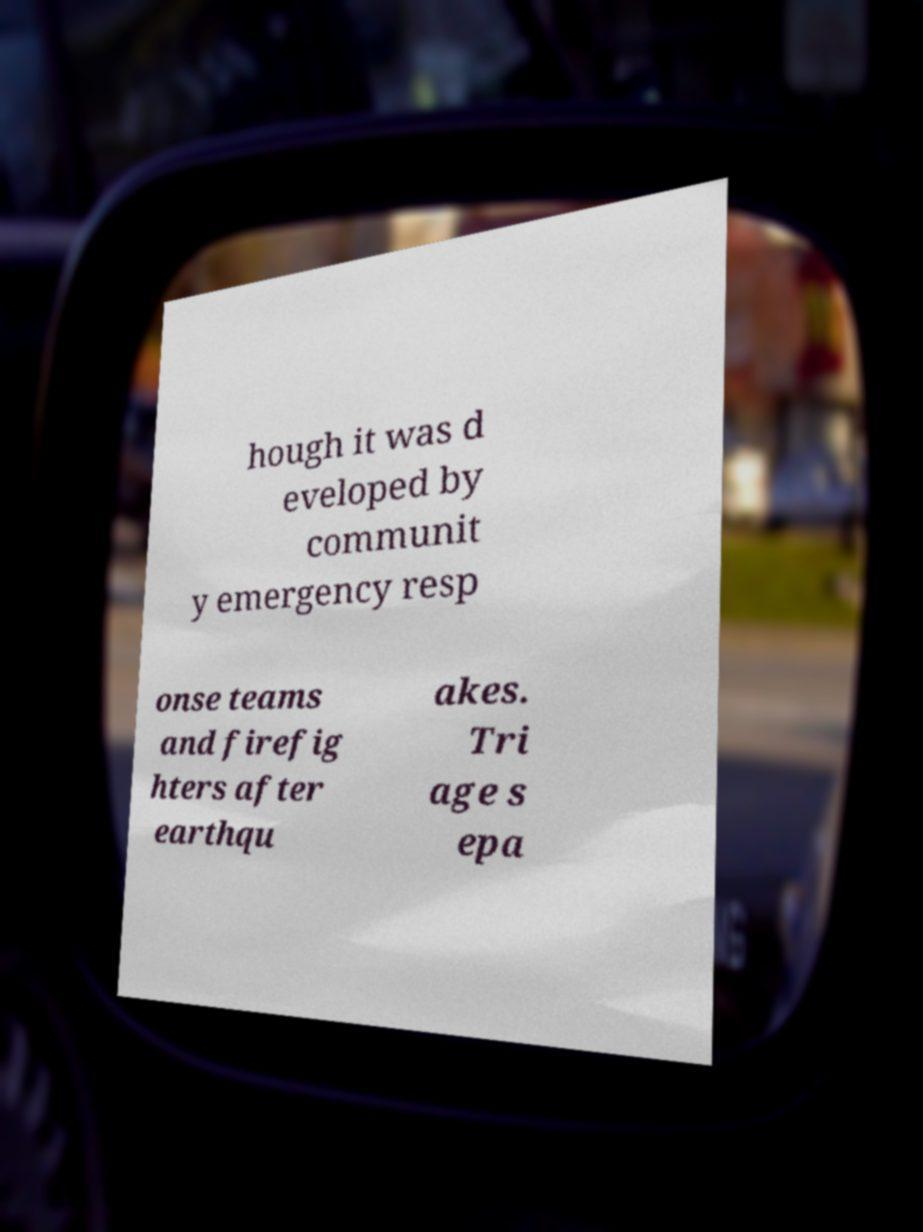Please read and relay the text visible in this image. What does it say? hough it was d eveloped by communit y emergency resp onse teams and firefig hters after earthqu akes. Tri age s epa 